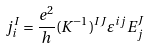Convert formula to latex. <formula><loc_0><loc_0><loc_500><loc_500>j ^ { I } _ { i } = \frac { e ^ { 2 } } { h } ( K ^ { - 1 } ) ^ { I J } \varepsilon ^ { i j } E _ { j } ^ { J }</formula> 